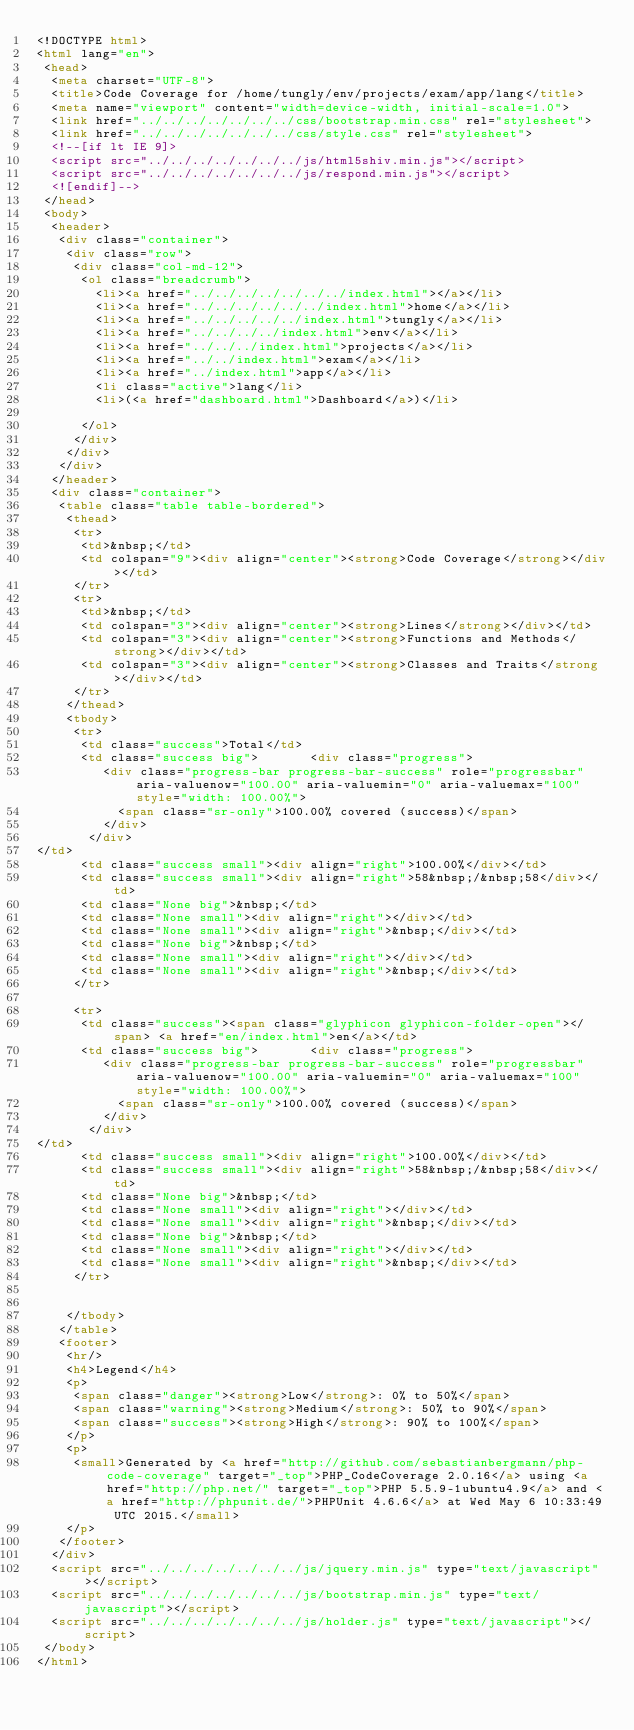Convert code to text. <code><loc_0><loc_0><loc_500><loc_500><_HTML_><!DOCTYPE html>
<html lang="en">
 <head>
  <meta charset="UTF-8">
  <title>Code Coverage for /home/tungly/env/projects/exam/app/lang</title>
  <meta name="viewport" content="width=device-width, initial-scale=1.0">
  <link href="../../../../../../../css/bootstrap.min.css" rel="stylesheet">
  <link href="../../../../../../../css/style.css" rel="stylesheet">
  <!--[if lt IE 9]>
  <script src="../../../../../../../js/html5shiv.min.js"></script>
  <script src="../../../../../../../js/respond.min.js"></script>
  <![endif]-->
 </head>
 <body>
  <header>
   <div class="container">
    <div class="row">
     <div class="col-md-12">
      <ol class="breadcrumb">
        <li><a href="../../../../../../../index.html"></a></li>
        <li><a href="../../../../../../index.html">home</a></li>
        <li><a href="../../../../../index.html">tungly</a></li>
        <li><a href="../../../../index.html">env</a></li>
        <li><a href="../../../index.html">projects</a></li>
        <li><a href="../../index.html">exam</a></li>
        <li><a href="../index.html">app</a></li>
        <li class="active">lang</li>
        <li>(<a href="dashboard.html">Dashboard</a>)</li>

      </ol>
     </div>
    </div>
   </div>
  </header>
  <div class="container">
   <table class="table table-bordered">
    <thead>
     <tr>
      <td>&nbsp;</td>
      <td colspan="9"><div align="center"><strong>Code Coverage</strong></div></td>
     </tr>
     <tr>
      <td>&nbsp;</td>
      <td colspan="3"><div align="center"><strong>Lines</strong></div></td>
      <td colspan="3"><div align="center"><strong>Functions and Methods</strong></div></td>
      <td colspan="3"><div align="center"><strong>Classes and Traits</strong></div></td>
     </tr>
    </thead>
    <tbody>
     <tr>
      <td class="success">Total</td>
      <td class="success big">       <div class="progress">
         <div class="progress-bar progress-bar-success" role="progressbar" aria-valuenow="100.00" aria-valuemin="0" aria-valuemax="100" style="width: 100.00%">
           <span class="sr-only">100.00% covered (success)</span>
         </div>
       </div>
</td>
      <td class="success small"><div align="right">100.00%</div></td>
      <td class="success small"><div align="right">58&nbsp;/&nbsp;58</div></td>
      <td class="None big">&nbsp;</td>
      <td class="None small"><div align="right"></div></td>
      <td class="None small"><div align="right">&nbsp;</div></td>
      <td class="None big">&nbsp;</td>
      <td class="None small"><div align="right"></div></td>
      <td class="None small"><div align="right">&nbsp;</div></td>
     </tr>

     <tr>
      <td class="success"><span class="glyphicon glyphicon-folder-open"></span> <a href="en/index.html">en</a></td>
      <td class="success big">       <div class="progress">
         <div class="progress-bar progress-bar-success" role="progressbar" aria-valuenow="100.00" aria-valuemin="0" aria-valuemax="100" style="width: 100.00%">
           <span class="sr-only">100.00% covered (success)</span>
         </div>
       </div>
</td>
      <td class="success small"><div align="right">100.00%</div></td>
      <td class="success small"><div align="right">58&nbsp;/&nbsp;58</div></td>
      <td class="None big">&nbsp;</td>
      <td class="None small"><div align="right"></div></td>
      <td class="None small"><div align="right">&nbsp;</div></td>
      <td class="None big">&nbsp;</td>
      <td class="None small"><div align="right"></div></td>
      <td class="None small"><div align="right">&nbsp;</div></td>
     </tr>


    </tbody>
   </table>
   <footer>
    <hr/>
    <h4>Legend</h4>
    <p>
     <span class="danger"><strong>Low</strong>: 0% to 50%</span>
     <span class="warning"><strong>Medium</strong>: 50% to 90%</span>
     <span class="success"><strong>High</strong>: 90% to 100%</span>
    </p>
    <p>
     <small>Generated by <a href="http://github.com/sebastianbergmann/php-code-coverage" target="_top">PHP_CodeCoverage 2.0.16</a> using <a href="http://php.net/" target="_top">PHP 5.5.9-1ubuntu4.9</a> and <a href="http://phpunit.de/">PHPUnit 4.6.6</a> at Wed May 6 10:33:49 UTC 2015.</small>
    </p>
   </footer>
  </div>
  <script src="../../../../../../../js/jquery.min.js" type="text/javascript"></script>
  <script src="../../../../../../../js/bootstrap.min.js" type="text/javascript"></script>
  <script src="../../../../../../../js/holder.js" type="text/javascript"></script>
 </body>
</html>
</code> 